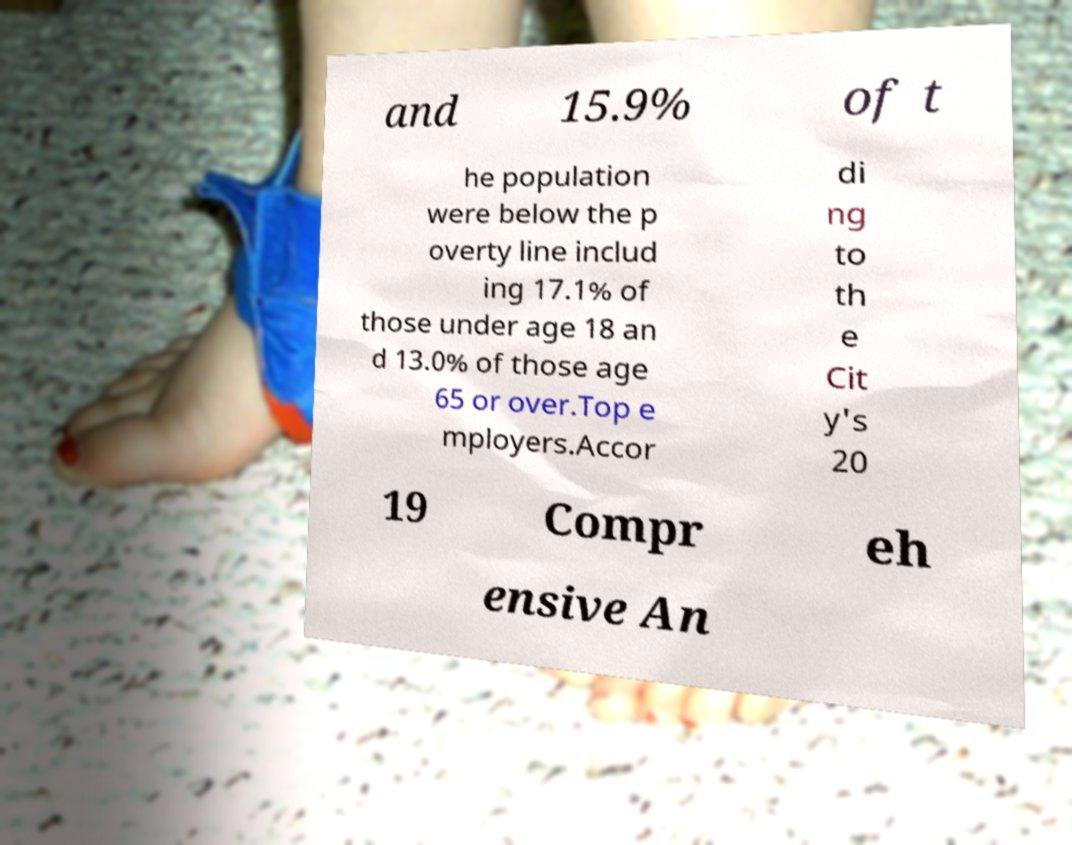Please read and relay the text visible in this image. What does it say? and 15.9% of t he population were below the p overty line includ ing 17.1% of those under age 18 an d 13.0% of those age 65 or over.Top e mployers.Accor di ng to th e Cit y's 20 19 Compr eh ensive An 